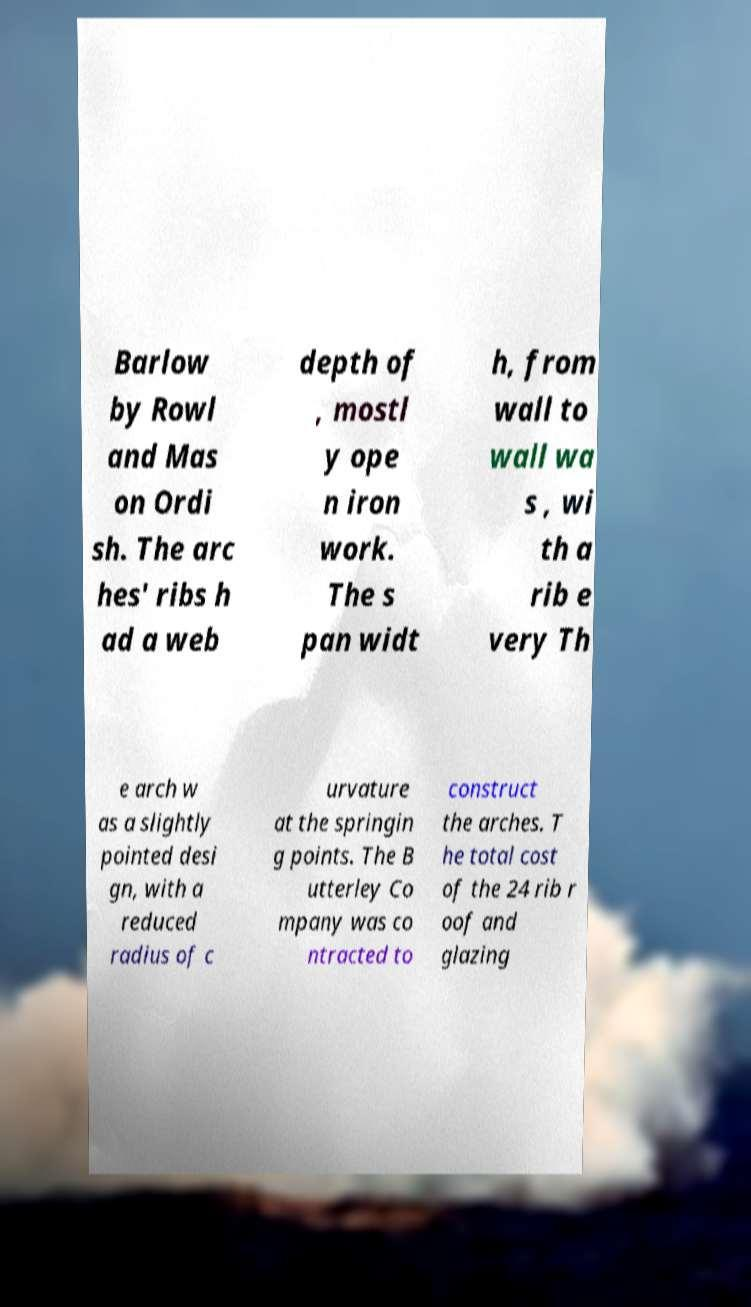Can you accurately transcribe the text from the provided image for me? Barlow by Rowl and Mas on Ordi sh. The arc hes' ribs h ad a web depth of , mostl y ope n iron work. The s pan widt h, from wall to wall wa s , wi th a rib e very Th e arch w as a slightly pointed desi gn, with a reduced radius of c urvature at the springin g points. The B utterley Co mpany was co ntracted to construct the arches. T he total cost of the 24 rib r oof and glazing 